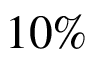<formula> <loc_0><loc_0><loc_500><loc_500>1 0 \%</formula> 